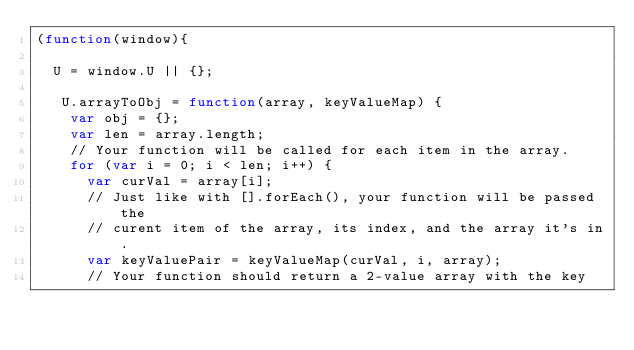<code> <loc_0><loc_0><loc_500><loc_500><_JavaScript_>(function(window){

	U = window.U || {};

	 U.arrayToObj = function(array, keyValueMap) {
		var obj = {};
		var len = array.length;
		// Your function will be called for each item in the array.
		for (var i = 0; i < len; i++) {
			var curVal = array[i];
			// Just like with [].forEach(), your function will be passed the
			// curent item of the array, its index, and the array it's in.
			var keyValuePair = keyValueMap(curVal, i, array);
			// Your function should return a 2-value array with the key</code> 